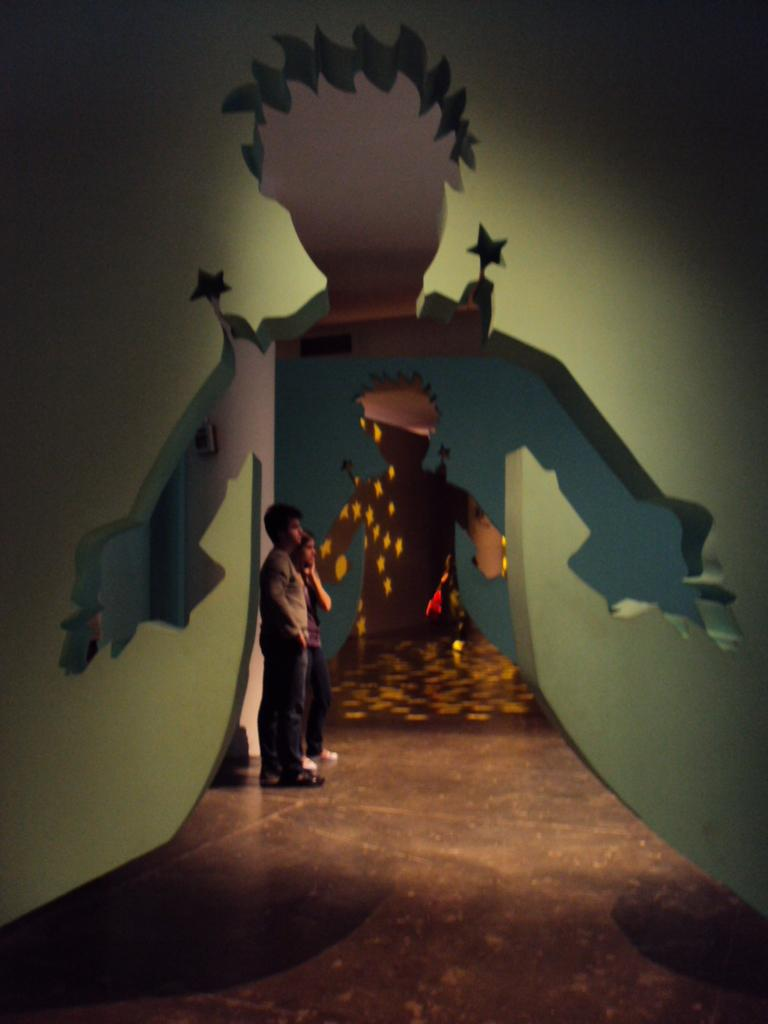How many people are in the image? There are two persons standing in the image. Where are the persons located in relation to the image? The persons are standing on the floor and are in the middle of the image. What can be seen in the background of the image? There is a hole in the wall in the background of the image. What is the shape of the hole in the wall? The hole is in the shape of a human. What type of record can be seen on the floor near the persons? There is no record present in the image. What is the persons' hope for the future, as depicted in the image? The image does not provide any information about the persons' hopes for the future. 